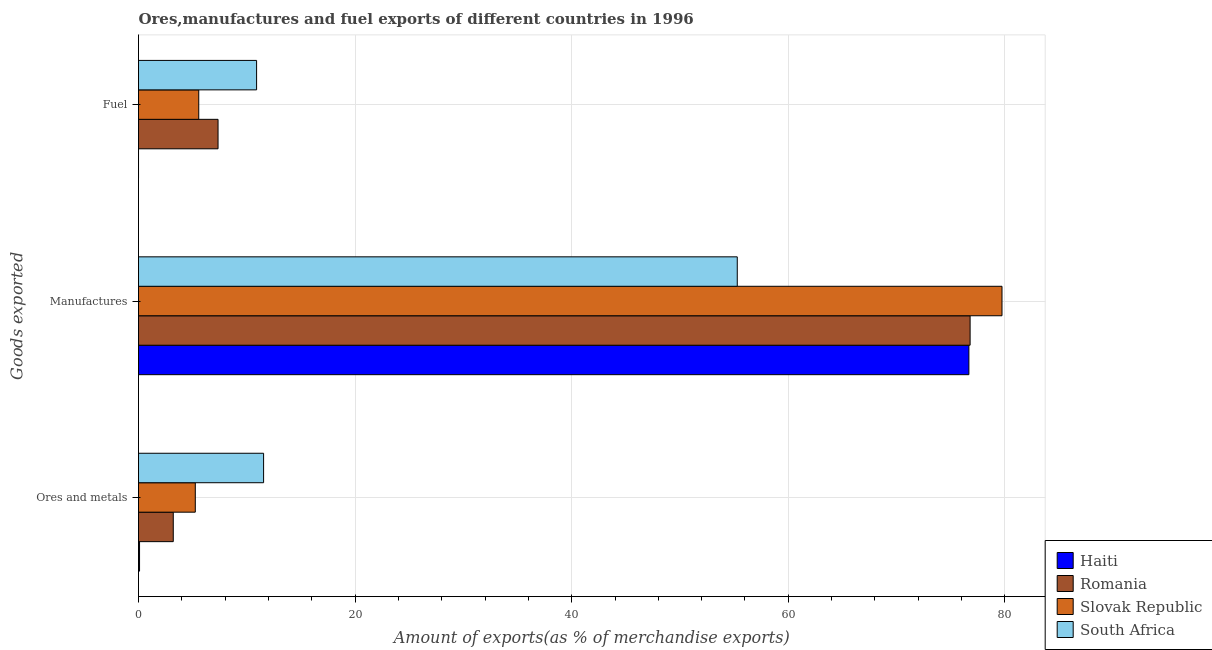How many different coloured bars are there?
Provide a succinct answer. 4. How many bars are there on the 1st tick from the bottom?
Ensure brevity in your answer.  4. What is the label of the 2nd group of bars from the top?
Give a very brief answer. Manufactures. What is the percentage of fuel exports in Slovak Republic?
Make the answer very short. 5.56. Across all countries, what is the maximum percentage of manufactures exports?
Make the answer very short. 79.74. Across all countries, what is the minimum percentage of ores and metals exports?
Make the answer very short. 0.1. In which country was the percentage of fuel exports maximum?
Your answer should be compact. South Africa. In which country was the percentage of ores and metals exports minimum?
Make the answer very short. Haiti. What is the total percentage of ores and metals exports in the graph?
Your response must be concise. 20.1. What is the difference between the percentage of manufactures exports in South Africa and that in Haiti?
Provide a short and direct response. -21.39. What is the difference between the percentage of manufactures exports in Haiti and the percentage of ores and metals exports in Romania?
Your answer should be compact. 73.47. What is the average percentage of manufactures exports per country?
Ensure brevity in your answer.  72.12. What is the difference between the percentage of fuel exports and percentage of ores and metals exports in Romania?
Keep it short and to the point. 4.13. What is the ratio of the percentage of fuel exports in Haiti to that in Romania?
Your answer should be very brief. 1.5761335368654215e-6. Is the difference between the percentage of fuel exports in Haiti and South Africa greater than the difference between the percentage of ores and metals exports in Haiti and South Africa?
Your answer should be very brief. Yes. What is the difference between the highest and the second highest percentage of fuel exports?
Your answer should be compact. 3.56. What is the difference between the highest and the lowest percentage of manufactures exports?
Offer a very short reply. 24.45. In how many countries, is the percentage of ores and metals exports greater than the average percentage of ores and metals exports taken over all countries?
Provide a short and direct response. 2. What does the 2nd bar from the top in Manufactures represents?
Keep it short and to the point. Slovak Republic. What does the 3rd bar from the bottom in Ores and metals represents?
Provide a short and direct response. Slovak Republic. Is it the case that in every country, the sum of the percentage of ores and metals exports and percentage of manufactures exports is greater than the percentage of fuel exports?
Your answer should be compact. Yes. How many bars are there?
Your answer should be compact. 12. Does the graph contain grids?
Your answer should be compact. Yes. Where does the legend appear in the graph?
Your answer should be compact. Bottom right. What is the title of the graph?
Provide a short and direct response. Ores,manufactures and fuel exports of different countries in 1996. What is the label or title of the X-axis?
Offer a very short reply. Amount of exports(as % of merchandise exports). What is the label or title of the Y-axis?
Your answer should be very brief. Goods exported. What is the Amount of exports(as % of merchandise exports) of Haiti in Ores and metals?
Ensure brevity in your answer.  0.1. What is the Amount of exports(as % of merchandise exports) in Romania in Ores and metals?
Keep it short and to the point. 3.21. What is the Amount of exports(as % of merchandise exports) in Slovak Republic in Ores and metals?
Keep it short and to the point. 5.24. What is the Amount of exports(as % of merchandise exports) of South Africa in Ores and metals?
Keep it short and to the point. 11.55. What is the Amount of exports(as % of merchandise exports) in Haiti in Manufactures?
Your response must be concise. 76.68. What is the Amount of exports(as % of merchandise exports) in Romania in Manufactures?
Your response must be concise. 76.79. What is the Amount of exports(as % of merchandise exports) of Slovak Republic in Manufactures?
Offer a very short reply. 79.74. What is the Amount of exports(as % of merchandise exports) in South Africa in Manufactures?
Make the answer very short. 55.29. What is the Amount of exports(as % of merchandise exports) of Haiti in Fuel?
Provide a short and direct response. 1.15759498066816e-5. What is the Amount of exports(as % of merchandise exports) of Romania in Fuel?
Your answer should be compact. 7.34. What is the Amount of exports(as % of merchandise exports) in Slovak Republic in Fuel?
Provide a succinct answer. 5.56. What is the Amount of exports(as % of merchandise exports) in South Africa in Fuel?
Offer a very short reply. 10.9. Across all Goods exported, what is the maximum Amount of exports(as % of merchandise exports) in Haiti?
Offer a very short reply. 76.68. Across all Goods exported, what is the maximum Amount of exports(as % of merchandise exports) of Romania?
Keep it short and to the point. 76.79. Across all Goods exported, what is the maximum Amount of exports(as % of merchandise exports) of Slovak Republic?
Give a very brief answer. 79.74. Across all Goods exported, what is the maximum Amount of exports(as % of merchandise exports) of South Africa?
Your answer should be compact. 55.29. Across all Goods exported, what is the minimum Amount of exports(as % of merchandise exports) of Haiti?
Give a very brief answer. 1.15759498066816e-5. Across all Goods exported, what is the minimum Amount of exports(as % of merchandise exports) in Romania?
Offer a very short reply. 3.21. Across all Goods exported, what is the minimum Amount of exports(as % of merchandise exports) of Slovak Republic?
Provide a short and direct response. 5.24. Across all Goods exported, what is the minimum Amount of exports(as % of merchandise exports) in South Africa?
Your answer should be very brief. 10.9. What is the total Amount of exports(as % of merchandise exports) of Haiti in the graph?
Make the answer very short. 76.77. What is the total Amount of exports(as % of merchandise exports) of Romania in the graph?
Give a very brief answer. 87.34. What is the total Amount of exports(as % of merchandise exports) in Slovak Republic in the graph?
Provide a short and direct response. 90.54. What is the total Amount of exports(as % of merchandise exports) of South Africa in the graph?
Ensure brevity in your answer.  77.74. What is the difference between the Amount of exports(as % of merchandise exports) in Haiti in Ores and metals and that in Manufactures?
Ensure brevity in your answer.  -76.58. What is the difference between the Amount of exports(as % of merchandise exports) of Romania in Ores and metals and that in Manufactures?
Keep it short and to the point. -73.58. What is the difference between the Amount of exports(as % of merchandise exports) of Slovak Republic in Ores and metals and that in Manufactures?
Your response must be concise. -74.49. What is the difference between the Amount of exports(as % of merchandise exports) in South Africa in Ores and metals and that in Manufactures?
Keep it short and to the point. -43.74. What is the difference between the Amount of exports(as % of merchandise exports) of Haiti in Ores and metals and that in Fuel?
Ensure brevity in your answer.  0.1. What is the difference between the Amount of exports(as % of merchandise exports) of Romania in Ores and metals and that in Fuel?
Ensure brevity in your answer.  -4.13. What is the difference between the Amount of exports(as % of merchandise exports) of Slovak Republic in Ores and metals and that in Fuel?
Give a very brief answer. -0.32. What is the difference between the Amount of exports(as % of merchandise exports) of South Africa in Ores and metals and that in Fuel?
Offer a terse response. 0.65. What is the difference between the Amount of exports(as % of merchandise exports) in Haiti in Manufactures and that in Fuel?
Provide a short and direct response. 76.68. What is the difference between the Amount of exports(as % of merchandise exports) of Romania in Manufactures and that in Fuel?
Your answer should be compact. 69.45. What is the difference between the Amount of exports(as % of merchandise exports) in Slovak Republic in Manufactures and that in Fuel?
Provide a short and direct response. 74.17. What is the difference between the Amount of exports(as % of merchandise exports) in South Africa in Manufactures and that in Fuel?
Provide a short and direct response. 44.39. What is the difference between the Amount of exports(as % of merchandise exports) in Haiti in Ores and metals and the Amount of exports(as % of merchandise exports) in Romania in Manufactures?
Your answer should be very brief. -76.69. What is the difference between the Amount of exports(as % of merchandise exports) in Haiti in Ores and metals and the Amount of exports(as % of merchandise exports) in Slovak Republic in Manufactures?
Your answer should be very brief. -79.64. What is the difference between the Amount of exports(as % of merchandise exports) in Haiti in Ores and metals and the Amount of exports(as % of merchandise exports) in South Africa in Manufactures?
Provide a succinct answer. -55.19. What is the difference between the Amount of exports(as % of merchandise exports) in Romania in Ores and metals and the Amount of exports(as % of merchandise exports) in Slovak Republic in Manufactures?
Offer a terse response. -76.53. What is the difference between the Amount of exports(as % of merchandise exports) in Romania in Ores and metals and the Amount of exports(as % of merchandise exports) in South Africa in Manufactures?
Ensure brevity in your answer.  -52.08. What is the difference between the Amount of exports(as % of merchandise exports) of Slovak Republic in Ores and metals and the Amount of exports(as % of merchandise exports) of South Africa in Manufactures?
Provide a succinct answer. -50.05. What is the difference between the Amount of exports(as % of merchandise exports) of Haiti in Ores and metals and the Amount of exports(as % of merchandise exports) of Romania in Fuel?
Your answer should be very brief. -7.25. What is the difference between the Amount of exports(as % of merchandise exports) of Haiti in Ores and metals and the Amount of exports(as % of merchandise exports) of Slovak Republic in Fuel?
Provide a short and direct response. -5.47. What is the difference between the Amount of exports(as % of merchandise exports) in Haiti in Ores and metals and the Amount of exports(as % of merchandise exports) in South Africa in Fuel?
Give a very brief answer. -10.81. What is the difference between the Amount of exports(as % of merchandise exports) of Romania in Ores and metals and the Amount of exports(as % of merchandise exports) of Slovak Republic in Fuel?
Make the answer very short. -2.35. What is the difference between the Amount of exports(as % of merchandise exports) of Romania in Ores and metals and the Amount of exports(as % of merchandise exports) of South Africa in Fuel?
Ensure brevity in your answer.  -7.69. What is the difference between the Amount of exports(as % of merchandise exports) of Slovak Republic in Ores and metals and the Amount of exports(as % of merchandise exports) of South Africa in Fuel?
Offer a terse response. -5.66. What is the difference between the Amount of exports(as % of merchandise exports) of Haiti in Manufactures and the Amount of exports(as % of merchandise exports) of Romania in Fuel?
Your response must be concise. 69.33. What is the difference between the Amount of exports(as % of merchandise exports) of Haiti in Manufactures and the Amount of exports(as % of merchandise exports) of Slovak Republic in Fuel?
Provide a succinct answer. 71.11. What is the difference between the Amount of exports(as % of merchandise exports) of Haiti in Manufactures and the Amount of exports(as % of merchandise exports) of South Africa in Fuel?
Your answer should be very brief. 65.77. What is the difference between the Amount of exports(as % of merchandise exports) in Romania in Manufactures and the Amount of exports(as % of merchandise exports) in Slovak Republic in Fuel?
Your response must be concise. 71.23. What is the difference between the Amount of exports(as % of merchandise exports) of Romania in Manufactures and the Amount of exports(as % of merchandise exports) of South Africa in Fuel?
Offer a terse response. 65.89. What is the difference between the Amount of exports(as % of merchandise exports) in Slovak Republic in Manufactures and the Amount of exports(as % of merchandise exports) in South Africa in Fuel?
Keep it short and to the point. 68.83. What is the average Amount of exports(as % of merchandise exports) of Haiti per Goods exported?
Keep it short and to the point. 25.59. What is the average Amount of exports(as % of merchandise exports) of Romania per Goods exported?
Your response must be concise. 29.11. What is the average Amount of exports(as % of merchandise exports) in Slovak Republic per Goods exported?
Your answer should be very brief. 30.18. What is the average Amount of exports(as % of merchandise exports) of South Africa per Goods exported?
Make the answer very short. 25.91. What is the difference between the Amount of exports(as % of merchandise exports) of Haiti and Amount of exports(as % of merchandise exports) of Romania in Ores and metals?
Your answer should be compact. -3.11. What is the difference between the Amount of exports(as % of merchandise exports) in Haiti and Amount of exports(as % of merchandise exports) in Slovak Republic in Ores and metals?
Your answer should be compact. -5.15. What is the difference between the Amount of exports(as % of merchandise exports) in Haiti and Amount of exports(as % of merchandise exports) in South Africa in Ores and metals?
Give a very brief answer. -11.45. What is the difference between the Amount of exports(as % of merchandise exports) in Romania and Amount of exports(as % of merchandise exports) in Slovak Republic in Ores and metals?
Keep it short and to the point. -2.03. What is the difference between the Amount of exports(as % of merchandise exports) of Romania and Amount of exports(as % of merchandise exports) of South Africa in Ores and metals?
Your answer should be very brief. -8.34. What is the difference between the Amount of exports(as % of merchandise exports) of Slovak Republic and Amount of exports(as % of merchandise exports) of South Africa in Ores and metals?
Keep it short and to the point. -6.31. What is the difference between the Amount of exports(as % of merchandise exports) of Haiti and Amount of exports(as % of merchandise exports) of Romania in Manufactures?
Your answer should be compact. -0.11. What is the difference between the Amount of exports(as % of merchandise exports) in Haiti and Amount of exports(as % of merchandise exports) in Slovak Republic in Manufactures?
Your answer should be compact. -3.06. What is the difference between the Amount of exports(as % of merchandise exports) of Haiti and Amount of exports(as % of merchandise exports) of South Africa in Manufactures?
Your response must be concise. 21.39. What is the difference between the Amount of exports(as % of merchandise exports) in Romania and Amount of exports(as % of merchandise exports) in Slovak Republic in Manufactures?
Provide a short and direct response. -2.94. What is the difference between the Amount of exports(as % of merchandise exports) in Romania and Amount of exports(as % of merchandise exports) in South Africa in Manufactures?
Ensure brevity in your answer.  21.5. What is the difference between the Amount of exports(as % of merchandise exports) in Slovak Republic and Amount of exports(as % of merchandise exports) in South Africa in Manufactures?
Give a very brief answer. 24.45. What is the difference between the Amount of exports(as % of merchandise exports) in Haiti and Amount of exports(as % of merchandise exports) in Romania in Fuel?
Give a very brief answer. -7.34. What is the difference between the Amount of exports(as % of merchandise exports) in Haiti and Amount of exports(as % of merchandise exports) in Slovak Republic in Fuel?
Your answer should be compact. -5.56. What is the difference between the Amount of exports(as % of merchandise exports) in Haiti and Amount of exports(as % of merchandise exports) in South Africa in Fuel?
Give a very brief answer. -10.9. What is the difference between the Amount of exports(as % of merchandise exports) in Romania and Amount of exports(as % of merchandise exports) in Slovak Republic in Fuel?
Give a very brief answer. 1.78. What is the difference between the Amount of exports(as % of merchandise exports) of Romania and Amount of exports(as % of merchandise exports) of South Africa in Fuel?
Your answer should be very brief. -3.56. What is the difference between the Amount of exports(as % of merchandise exports) of Slovak Republic and Amount of exports(as % of merchandise exports) of South Africa in Fuel?
Your response must be concise. -5.34. What is the ratio of the Amount of exports(as % of merchandise exports) of Haiti in Ores and metals to that in Manufactures?
Offer a terse response. 0. What is the ratio of the Amount of exports(as % of merchandise exports) of Romania in Ores and metals to that in Manufactures?
Give a very brief answer. 0.04. What is the ratio of the Amount of exports(as % of merchandise exports) in Slovak Republic in Ores and metals to that in Manufactures?
Give a very brief answer. 0.07. What is the ratio of the Amount of exports(as % of merchandise exports) of South Africa in Ores and metals to that in Manufactures?
Offer a very short reply. 0.21. What is the ratio of the Amount of exports(as % of merchandise exports) of Haiti in Ores and metals to that in Fuel?
Your answer should be compact. 8344.83. What is the ratio of the Amount of exports(as % of merchandise exports) of Romania in Ores and metals to that in Fuel?
Provide a short and direct response. 0.44. What is the ratio of the Amount of exports(as % of merchandise exports) in Slovak Republic in Ores and metals to that in Fuel?
Your answer should be very brief. 0.94. What is the ratio of the Amount of exports(as % of merchandise exports) in South Africa in Ores and metals to that in Fuel?
Make the answer very short. 1.06. What is the ratio of the Amount of exports(as % of merchandise exports) in Haiti in Manufactures to that in Fuel?
Give a very brief answer. 6.62e+06. What is the ratio of the Amount of exports(as % of merchandise exports) of Romania in Manufactures to that in Fuel?
Offer a terse response. 10.46. What is the ratio of the Amount of exports(as % of merchandise exports) in Slovak Republic in Manufactures to that in Fuel?
Make the answer very short. 14.33. What is the ratio of the Amount of exports(as % of merchandise exports) in South Africa in Manufactures to that in Fuel?
Your answer should be compact. 5.07. What is the difference between the highest and the second highest Amount of exports(as % of merchandise exports) in Haiti?
Offer a very short reply. 76.58. What is the difference between the highest and the second highest Amount of exports(as % of merchandise exports) of Romania?
Make the answer very short. 69.45. What is the difference between the highest and the second highest Amount of exports(as % of merchandise exports) of Slovak Republic?
Offer a terse response. 74.17. What is the difference between the highest and the second highest Amount of exports(as % of merchandise exports) of South Africa?
Provide a short and direct response. 43.74. What is the difference between the highest and the lowest Amount of exports(as % of merchandise exports) in Haiti?
Your response must be concise. 76.68. What is the difference between the highest and the lowest Amount of exports(as % of merchandise exports) of Romania?
Offer a terse response. 73.58. What is the difference between the highest and the lowest Amount of exports(as % of merchandise exports) of Slovak Republic?
Your response must be concise. 74.49. What is the difference between the highest and the lowest Amount of exports(as % of merchandise exports) of South Africa?
Offer a very short reply. 44.39. 